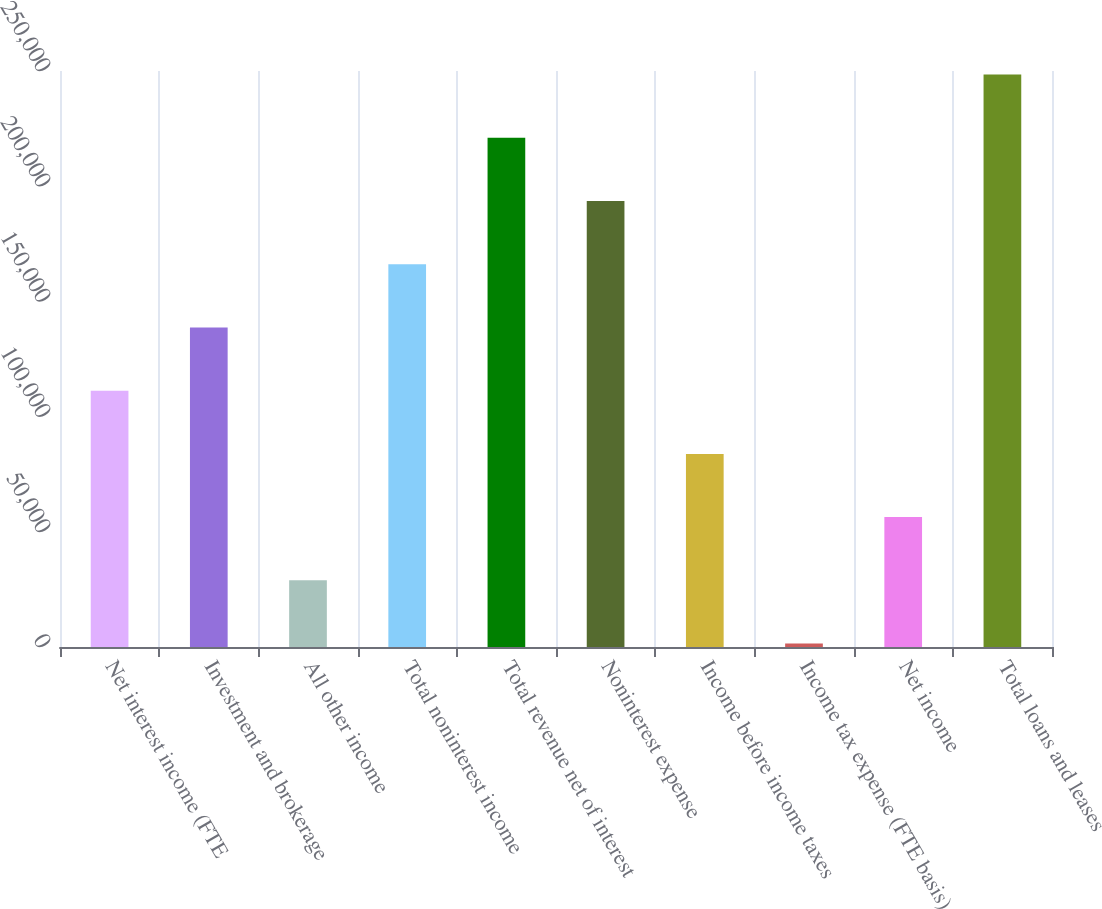Convert chart to OTSL. <chart><loc_0><loc_0><loc_500><loc_500><bar_chart><fcel>Net interest income (FTE<fcel>Investment and brokerage<fcel>All other income<fcel>Total noninterest income<fcel>Total revenue net of interest<fcel>Noninterest expense<fcel>Income before income taxes<fcel>Income tax expense (FTE basis)<fcel>Net income<fcel>Total loans and leases<nl><fcel>111245<fcel>138682<fcel>28934.8<fcel>166119<fcel>220992<fcel>193556<fcel>83808.4<fcel>1498<fcel>56371.6<fcel>248429<nl></chart> 